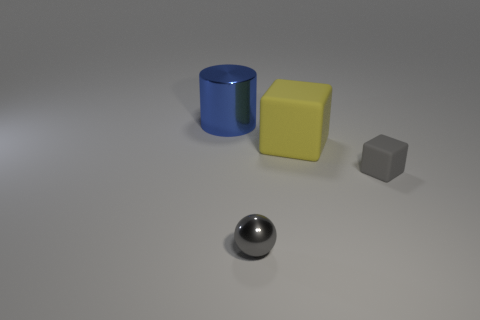What objects are present in the image, and what are their colors and shapes? The image shows four distinct objects: a blue cylindrical can, a yellow cube, a grey cube, and a metallic sphere. The objects are evenly spaced and placed against a neutral background to highlight their shapes and colors. 